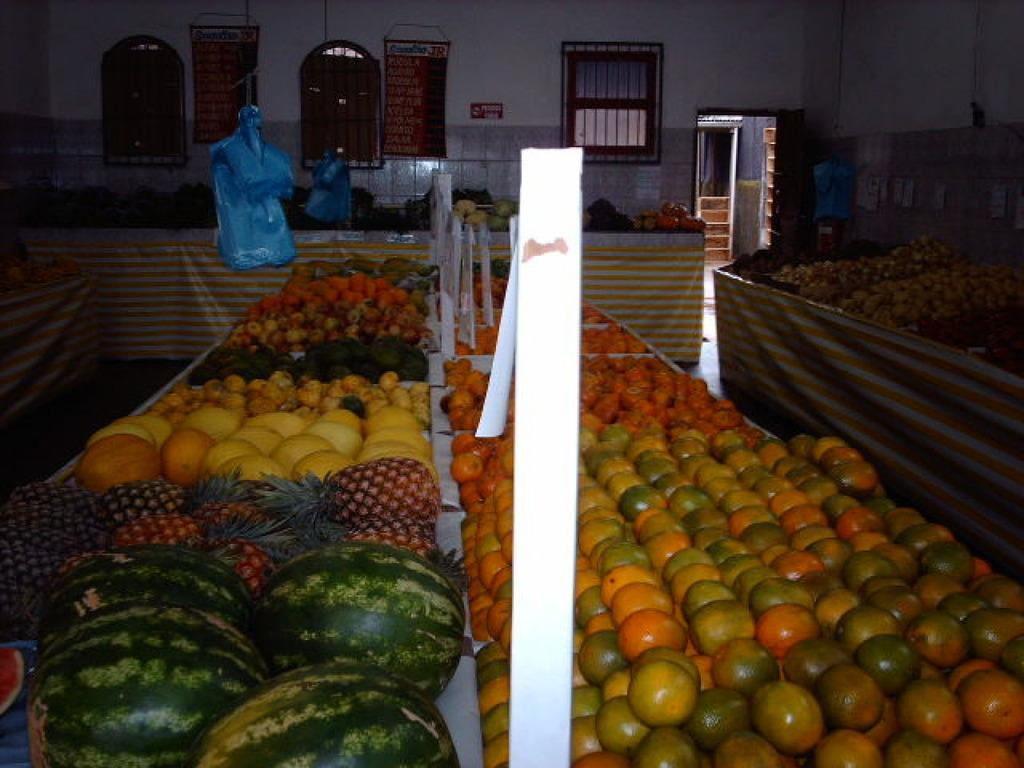What types of food items are present in the image? There are fruits and vegetables in the image. Can you describe the variety of colors in the image? The fruits and vegetables are in multiple colors. What can be seen in the background of the image? There are windows and stairs in the background of the image, and the wall is white. What type of chin can be seen on the zephyr in the image? There is no zephyr or chin present in the image; it features fruits and vegetables with a white wall and windows in the background. 